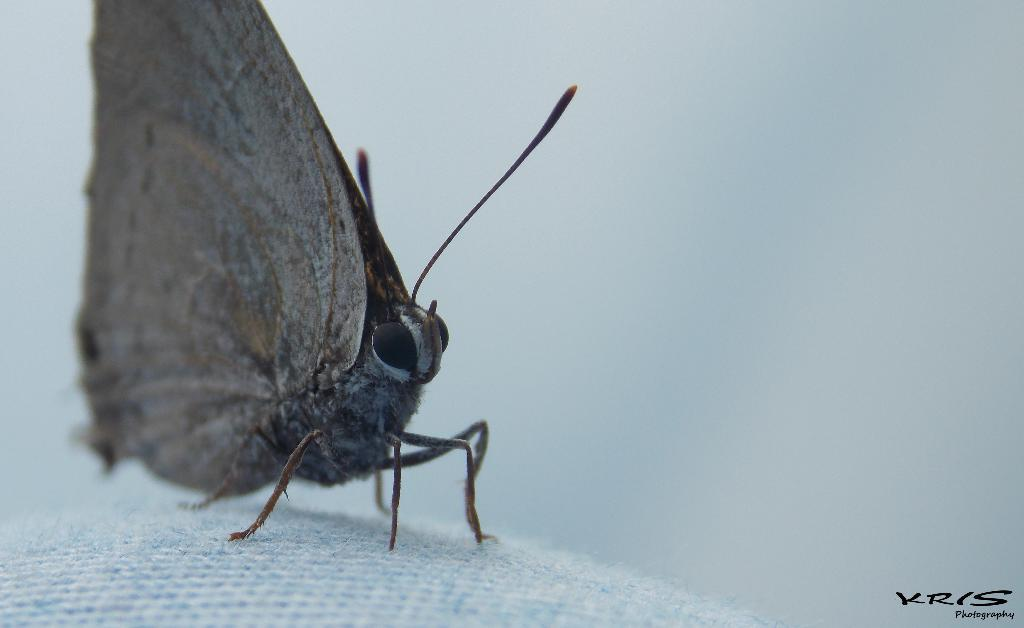What is the main subject of the image? There is a butterfly in the image. Where is the butterfly located? The butterfly is on a cloth. Can you describe the background of the image? The background of the image is blurry. Is there any text present in the image? Yes, there is some text in the bottom right corner of the image. What type of fear can be seen on the playground in the image? There is no playground or fear present in the image; it features a butterfly on a cloth with a blurry background and some text in the bottom right corner. 